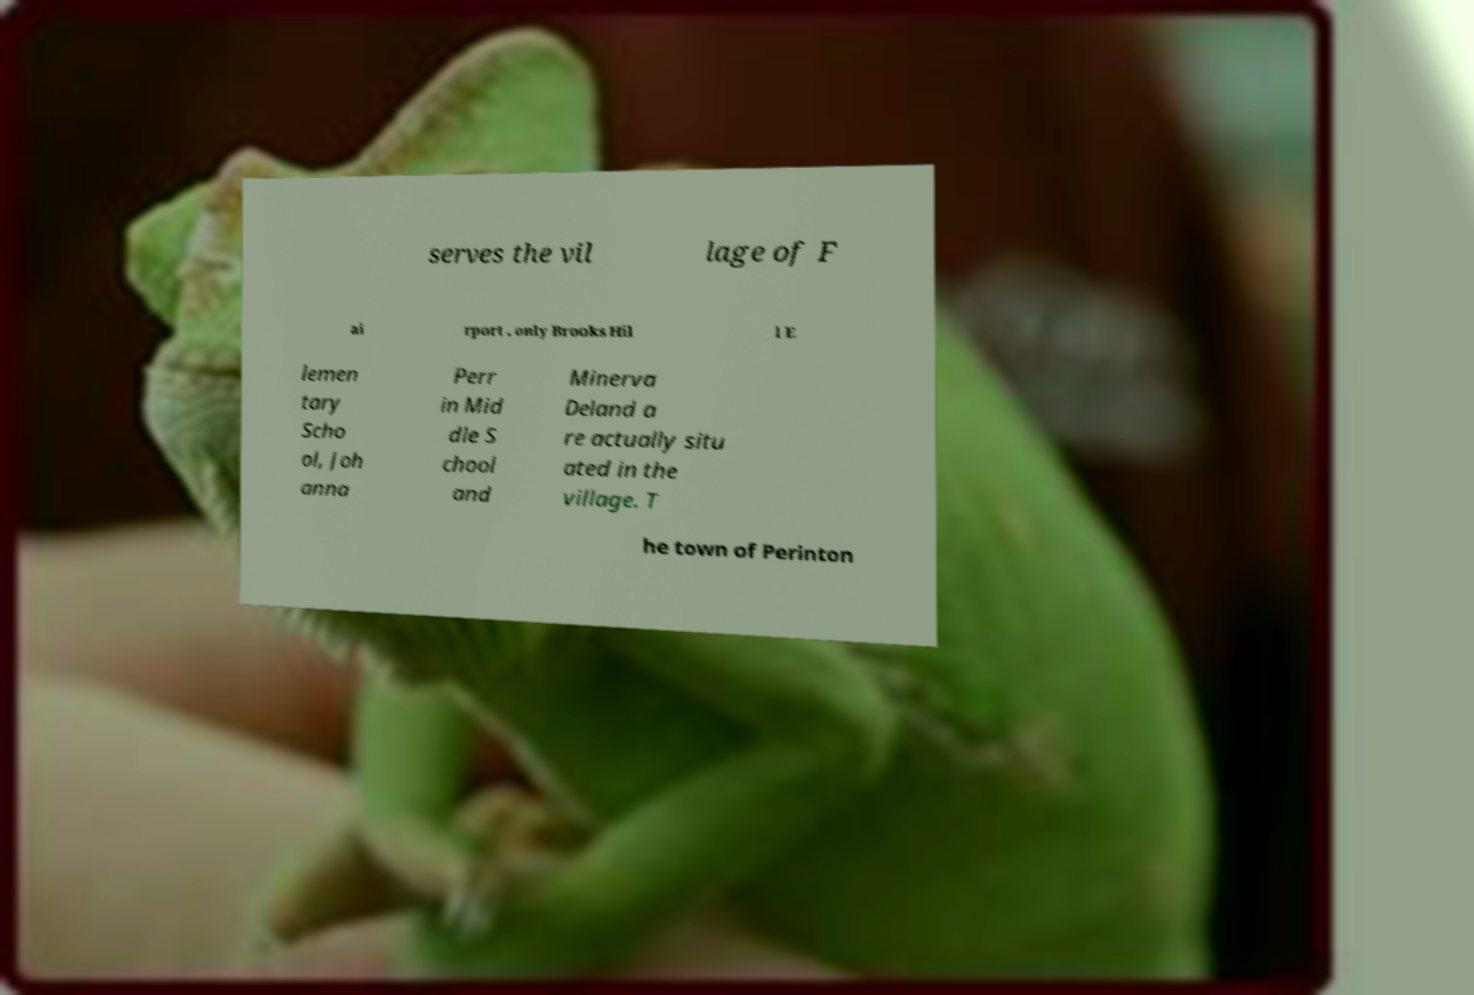Can you accurately transcribe the text from the provided image for me? serves the vil lage of F ai rport , only Brooks Hil l E lemen tary Scho ol, Joh anna Perr in Mid dle S chool and Minerva Deland a re actually situ ated in the village. T he town of Perinton 